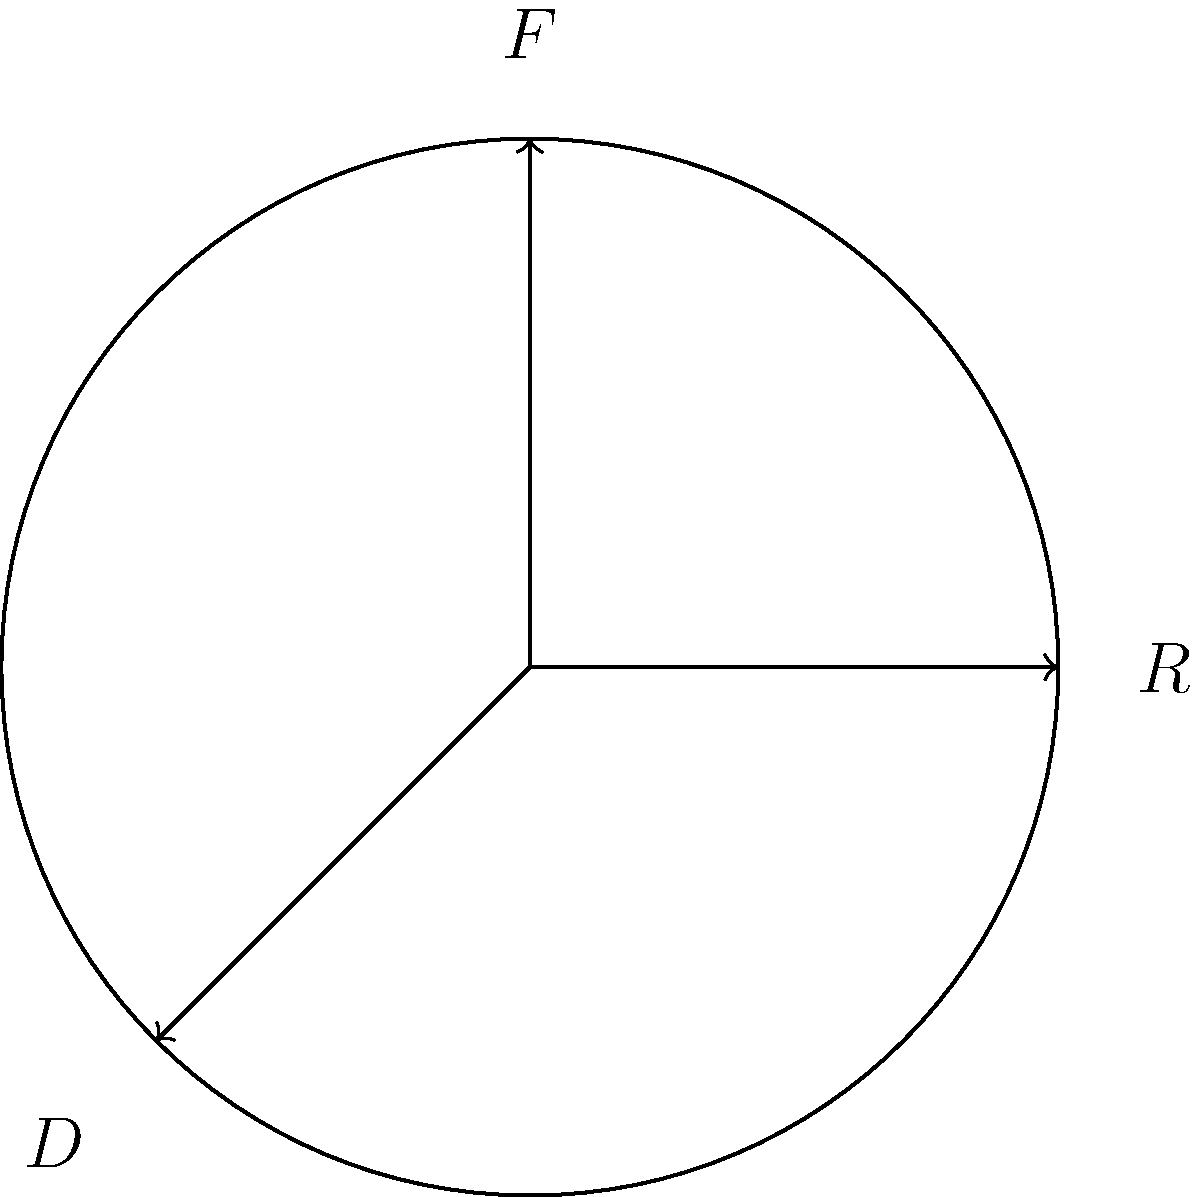In the context of classic film reels, consider the symmetry group of a circular film reel. What is the order of this group, and what are its elements? (Hint: Think about the rotations and reflections that preserve the shape of the reel, similar to how Christopher Plummer's performances in classic films preserve their timeless appeal.) Let's approach this step-by-step:

1) First, we need to identify the symmetries of a circular film reel:

   a) Rotations: The reel can be rotated by any angle and still look the same. This gives us infinite rotational symmetry.
   b) Reflections: The reel has an infinite number of lines of reflection (any diameter).

2) However, in group theory, we typically consider only the discrete symmetry group. For a circle, this is the dihedral group of order infinity, denoted as $D_\infty$.

3) The elements of $D_\infty$ are:
   
   a) Rotations by any angle $\theta$, denoted as $R_\theta$.
   b) Reflections across any diameter, denoted as $F_\phi$, where $\phi$ is the angle the diameter makes with a fixed axis.

4) The group operations are:

   a) $R_\theta R_\phi = R_{\theta+\phi}$
   b) $F_\phi F_\theta = R_{2(\phi-\theta)}$
   c) $R_\theta F_\phi = F_{\phi-\theta}$
   d) $F_\phi R_\theta = F_{\phi+\theta}$

5) The order of this group is infinite, as there are infinitely many possible rotations and reflections.

This symmetry group reflects the timeless nature of classic films, much like how Christopher Plummer's performances in films like "The Sound of Music" can be viewed and appreciated from any angle or perspective.
Answer: $D_\infty$; $\{R_\theta, F_\phi | \theta, \phi \in \mathbb{R}\}$ 